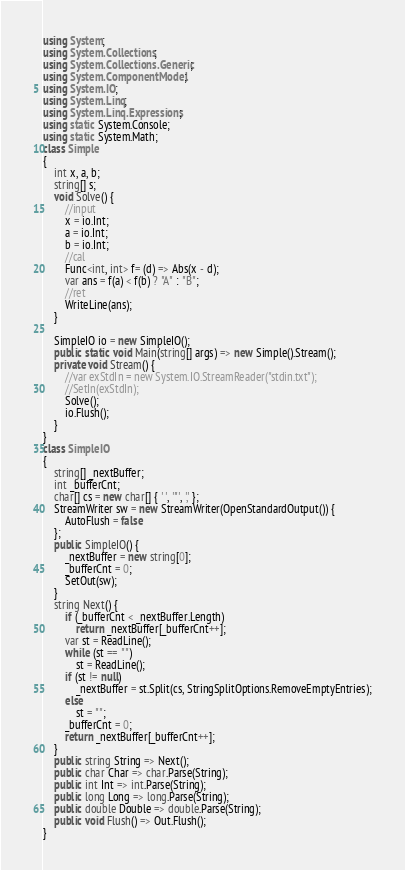Convert code to text. <code><loc_0><loc_0><loc_500><loc_500><_C#_>using System;
using System.Collections;
using System.Collections.Generic;
using System.ComponentModel;
using System.IO;
using System.Linq;
using System.Linq.Expressions;
using static System.Console;
using static System.Math;
class Simple
{
    int x, a, b;
    string[] s;
    void Solve() {
        //input
        x = io.Int;
        a = io.Int;
        b = io.Int;
        //cal
        Func<int, int> f= (d) => Abs(x - d);
        var ans = f(a) < f(b) ? "A" : "B";
        //ret
        WriteLine(ans);
    }

    SimpleIO io = new SimpleIO();
    public static void Main(string[] args) => new Simple().Stream();
    private void Stream() {
        //var exStdIn = new System.IO.StreamReader("stdin.txt");
        //SetIn(exStdIn);
        Solve();
        io.Flush();
    }
}
class SimpleIO
{
    string[] _nextBuffer;
    int _bufferCnt;
    char[] cs = new char[] { ' ', '"', ',' };
    StreamWriter sw = new StreamWriter(OpenStandardOutput()) {
        AutoFlush = false
    };
    public SimpleIO() {
        _nextBuffer = new string[0];
        _bufferCnt = 0;
        SetOut(sw);
    }
    string Next() {
        if (_bufferCnt < _nextBuffer.Length)
            return _nextBuffer[_bufferCnt++];
        var st = ReadLine();
        while (st == "")
            st = ReadLine();
        if (st != null)
            _nextBuffer = st.Split(cs, StringSplitOptions.RemoveEmptyEntries);
        else
            st = "";
        _bufferCnt = 0;
        return _nextBuffer[_bufferCnt++];
    }
    public string String => Next();
    public char Char => char.Parse(String);
    public int Int => int.Parse(String);
    public long Long => long.Parse(String);
    public double Double => double.Parse(String);
    public void Flush() => Out.Flush();
}
</code> 